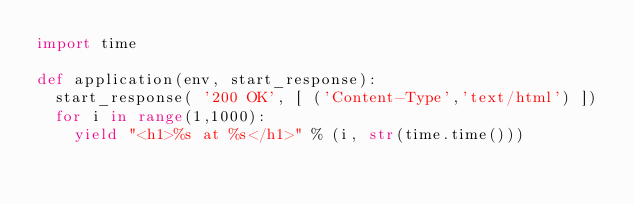<code> <loc_0><loc_0><loc_500><loc_500><_Python_>import time

def application(env, start_response):
	start_response( '200 OK', [ ('Content-Type','text/html') ])
	for i in range(1,1000):
		yield "<h1>%s at %s</h1>" % (i, str(time.time()))
</code> 